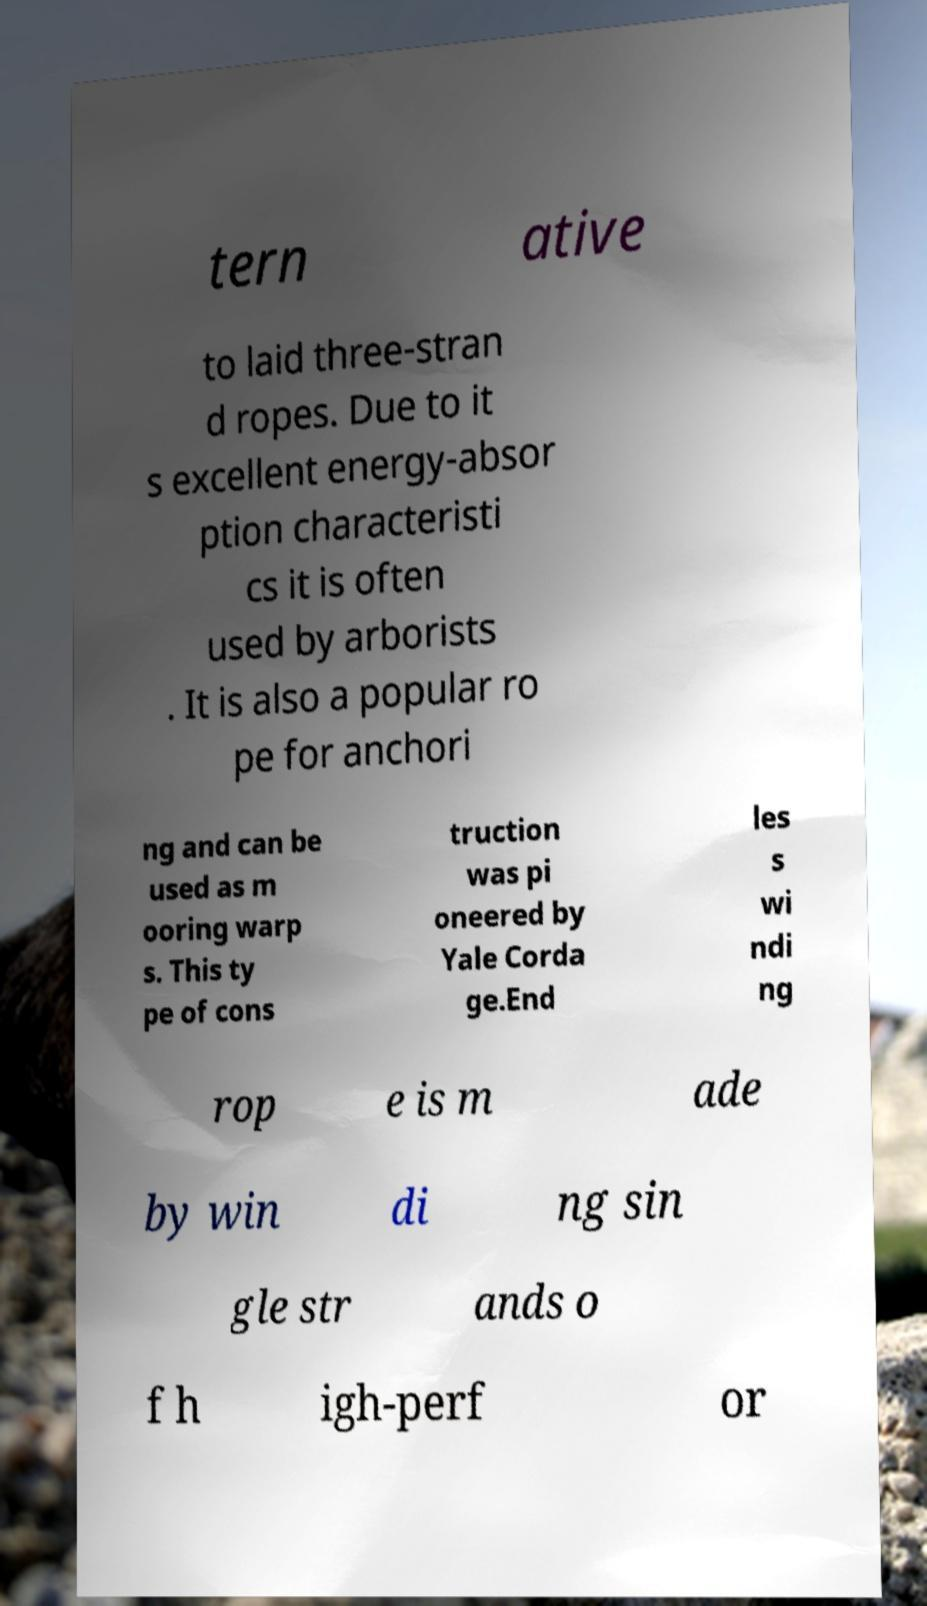Could you assist in decoding the text presented in this image and type it out clearly? tern ative to laid three-stran d ropes. Due to it s excellent energy-absor ption characteristi cs it is often used by arborists . It is also a popular ro pe for anchori ng and can be used as m ooring warp s. This ty pe of cons truction was pi oneered by Yale Corda ge.End les s wi ndi ng rop e is m ade by win di ng sin gle str ands o f h igh-perf or 